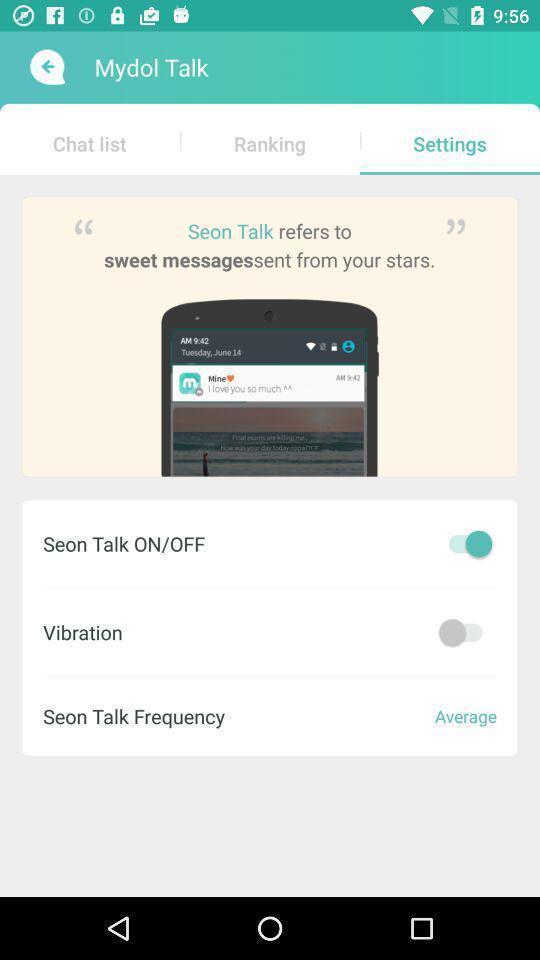Summarize the main components in this picture. Screen shows few settings on a caller app. 